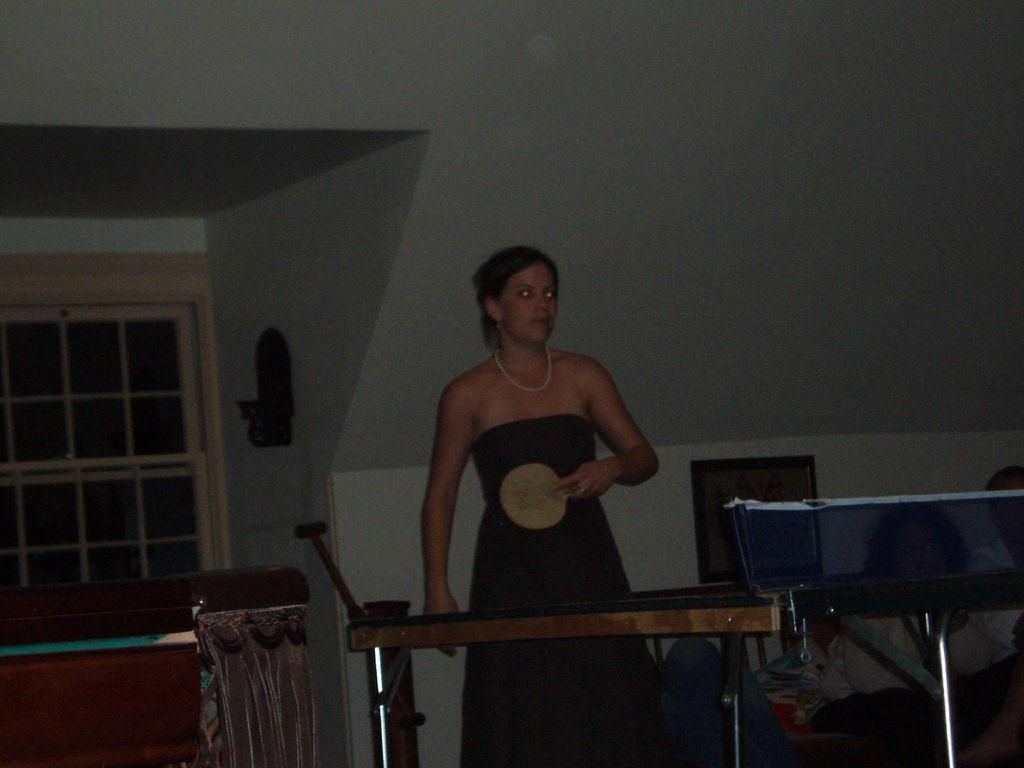Who is the main subject in the image? There is a lady in the image. What is the lady wearing? The lady is wearing a black dress. What object is the lady holding in the image? The lady is holding a bat. What type of grass can be seen growing on the furniture in the image? There is no grass or furniture present in the image; it features a lady holding a bat. 